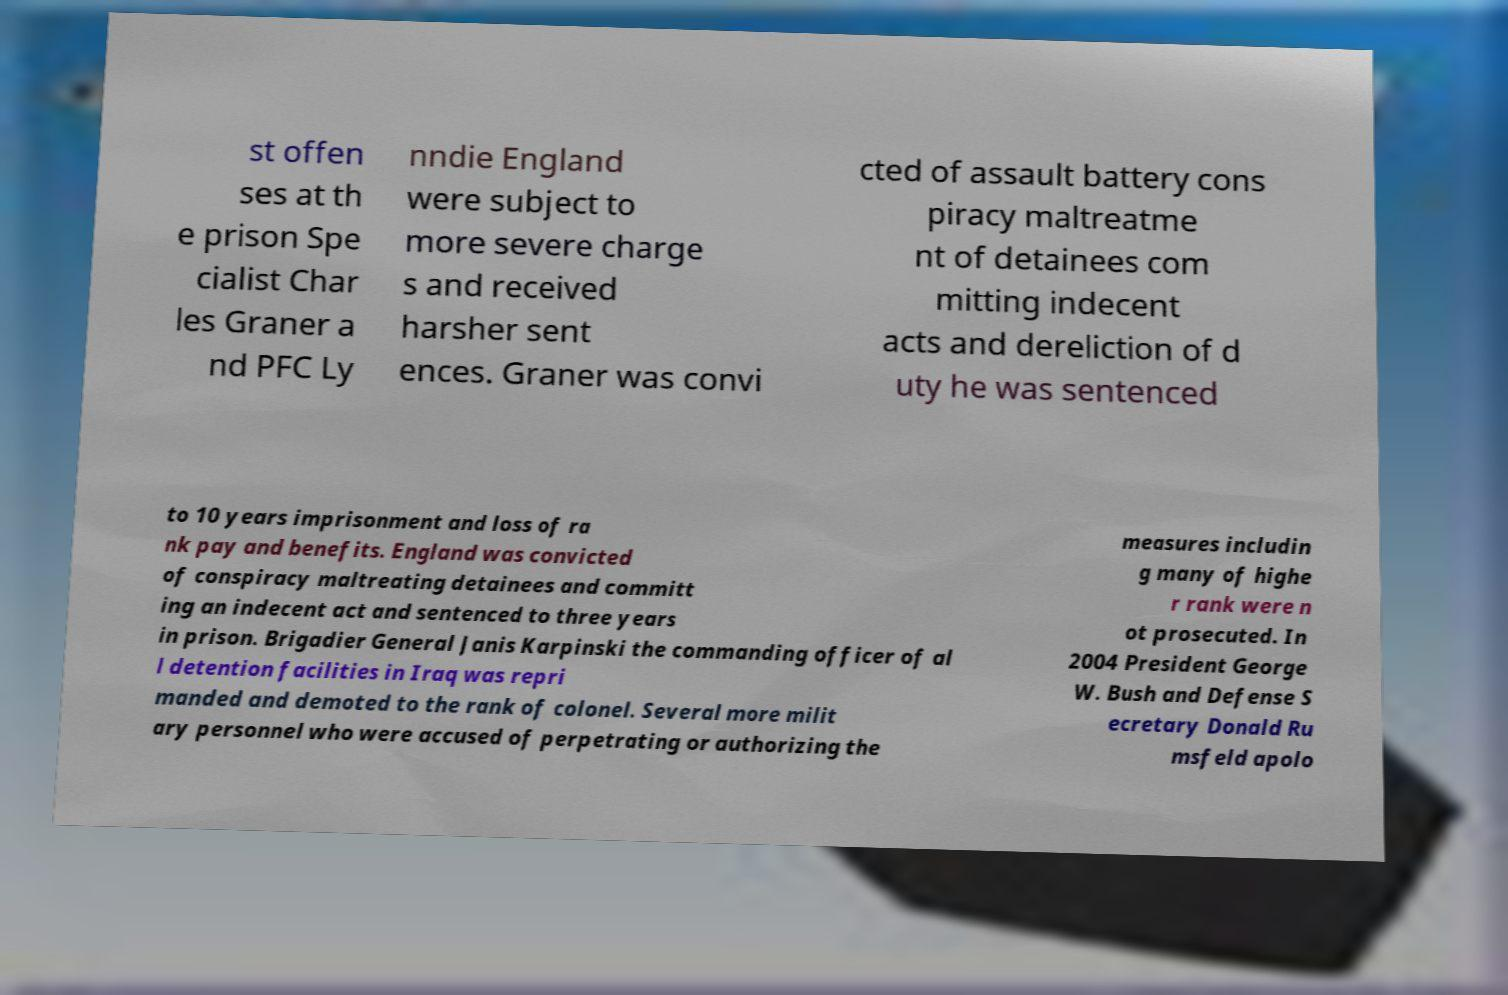There's text embedded in this image that I need extracted. Can you transcribe it verbatim? st offen ses at th e prison Spe cialist Char les Graner a nd PFC Ly nndie England were subject to more severe charge s and received harsher sent ences. Graner was convi cted of assault battery cons piracy maltreatme nt of detainees com mitting indecent acts and dereliction of d uty he was sentenced to 10 years imprisonment and loss of ra nk pay and benefits. England was convicted of conspiracy maltreating detainees and committ ing an indecent act and sentenced to three years in prison. Brigadier General Janis Karpinski the commanding officer of al l detention facilities in Iraq was repri manded and demoted to the rank of colonel. Several more milit ary personnel who were accused of perpetrating or authorizing the measures includin g many of highe r rank were n ot prosecuted. In 2004 President George W. Bush and Defense S ecretary Donald Ru msfeld apolo 